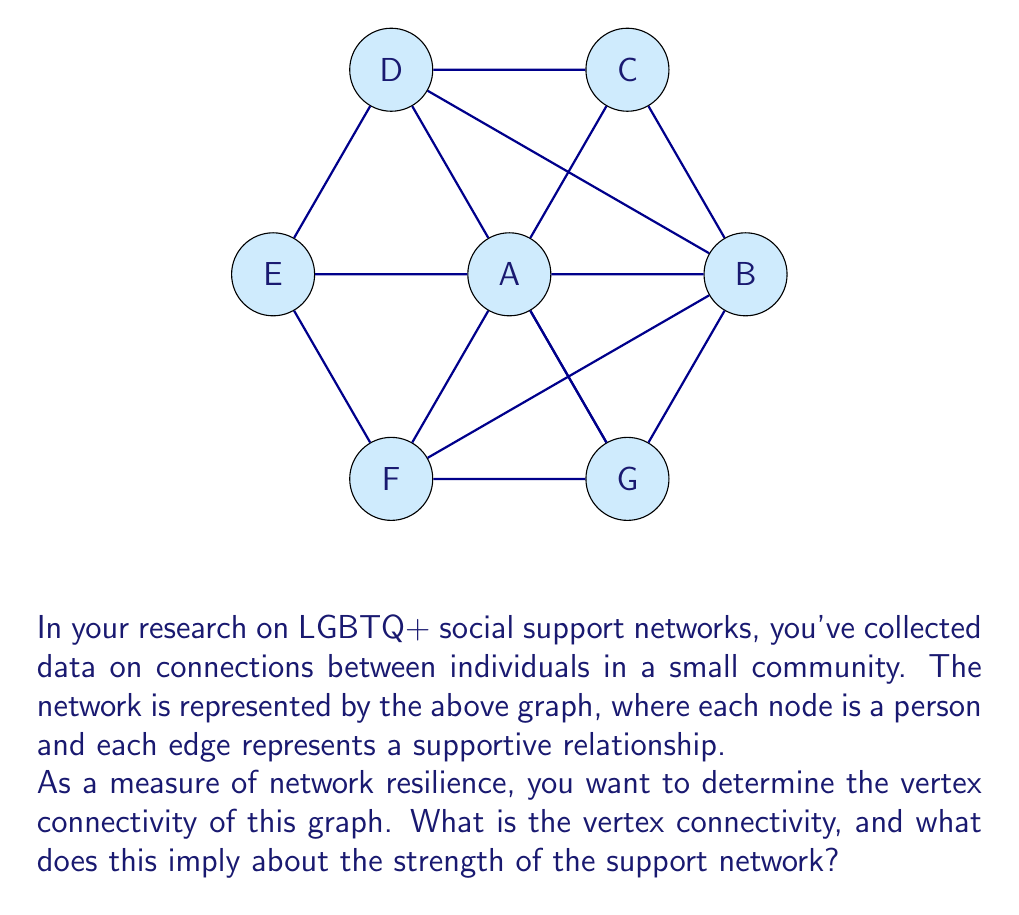Show me your answer to this math problem. To solve this problem, we need to understand and calculate the vertex connectivity of the given graph. Let's go through this step-by-step:

1) Vertex connectivity is defined as the minimum number of vertices that need to be removed to disconnect the graph.

2) To find the vertex connectivity, we need to consider all possible ways to disconnect the graph by removing vertices.

3) Let's analyze the graph:
   - It has 7 vertices (A, B, C, D, E, F, G)
   - Each vertex is connected to at least 4 other vertices
   - Vertex A is connected to all other vertices

4) If we remove any single vertex, the graph remains connected:
   - Removing A leaves a 6-vertex cycle, which is connected
   - Removing any other vertex leaves A connected to the remaining 5 vertices

5) If we remove any two vertices, the graph also remains connected:
   - Even if we remove A and any other vertex, the remaining 5 vertices form a connected subgraph

6) If we remove three vertices carefully chosen, we can disconnect the graph:
   - For example, removing A, B, and E disconnects C and G from D and F

7) Therefore, the vertex connectivity of this graph is 3.

This implies that the LGBTQ+ support network represented by this graph is relatively strong and resilient. It would take the removal of at least 3 individuals to break the network into disconnected components, suggesting that support and connections in this community are well-distributed and not overly dependent on any one or two individuals.
Answer: 3 